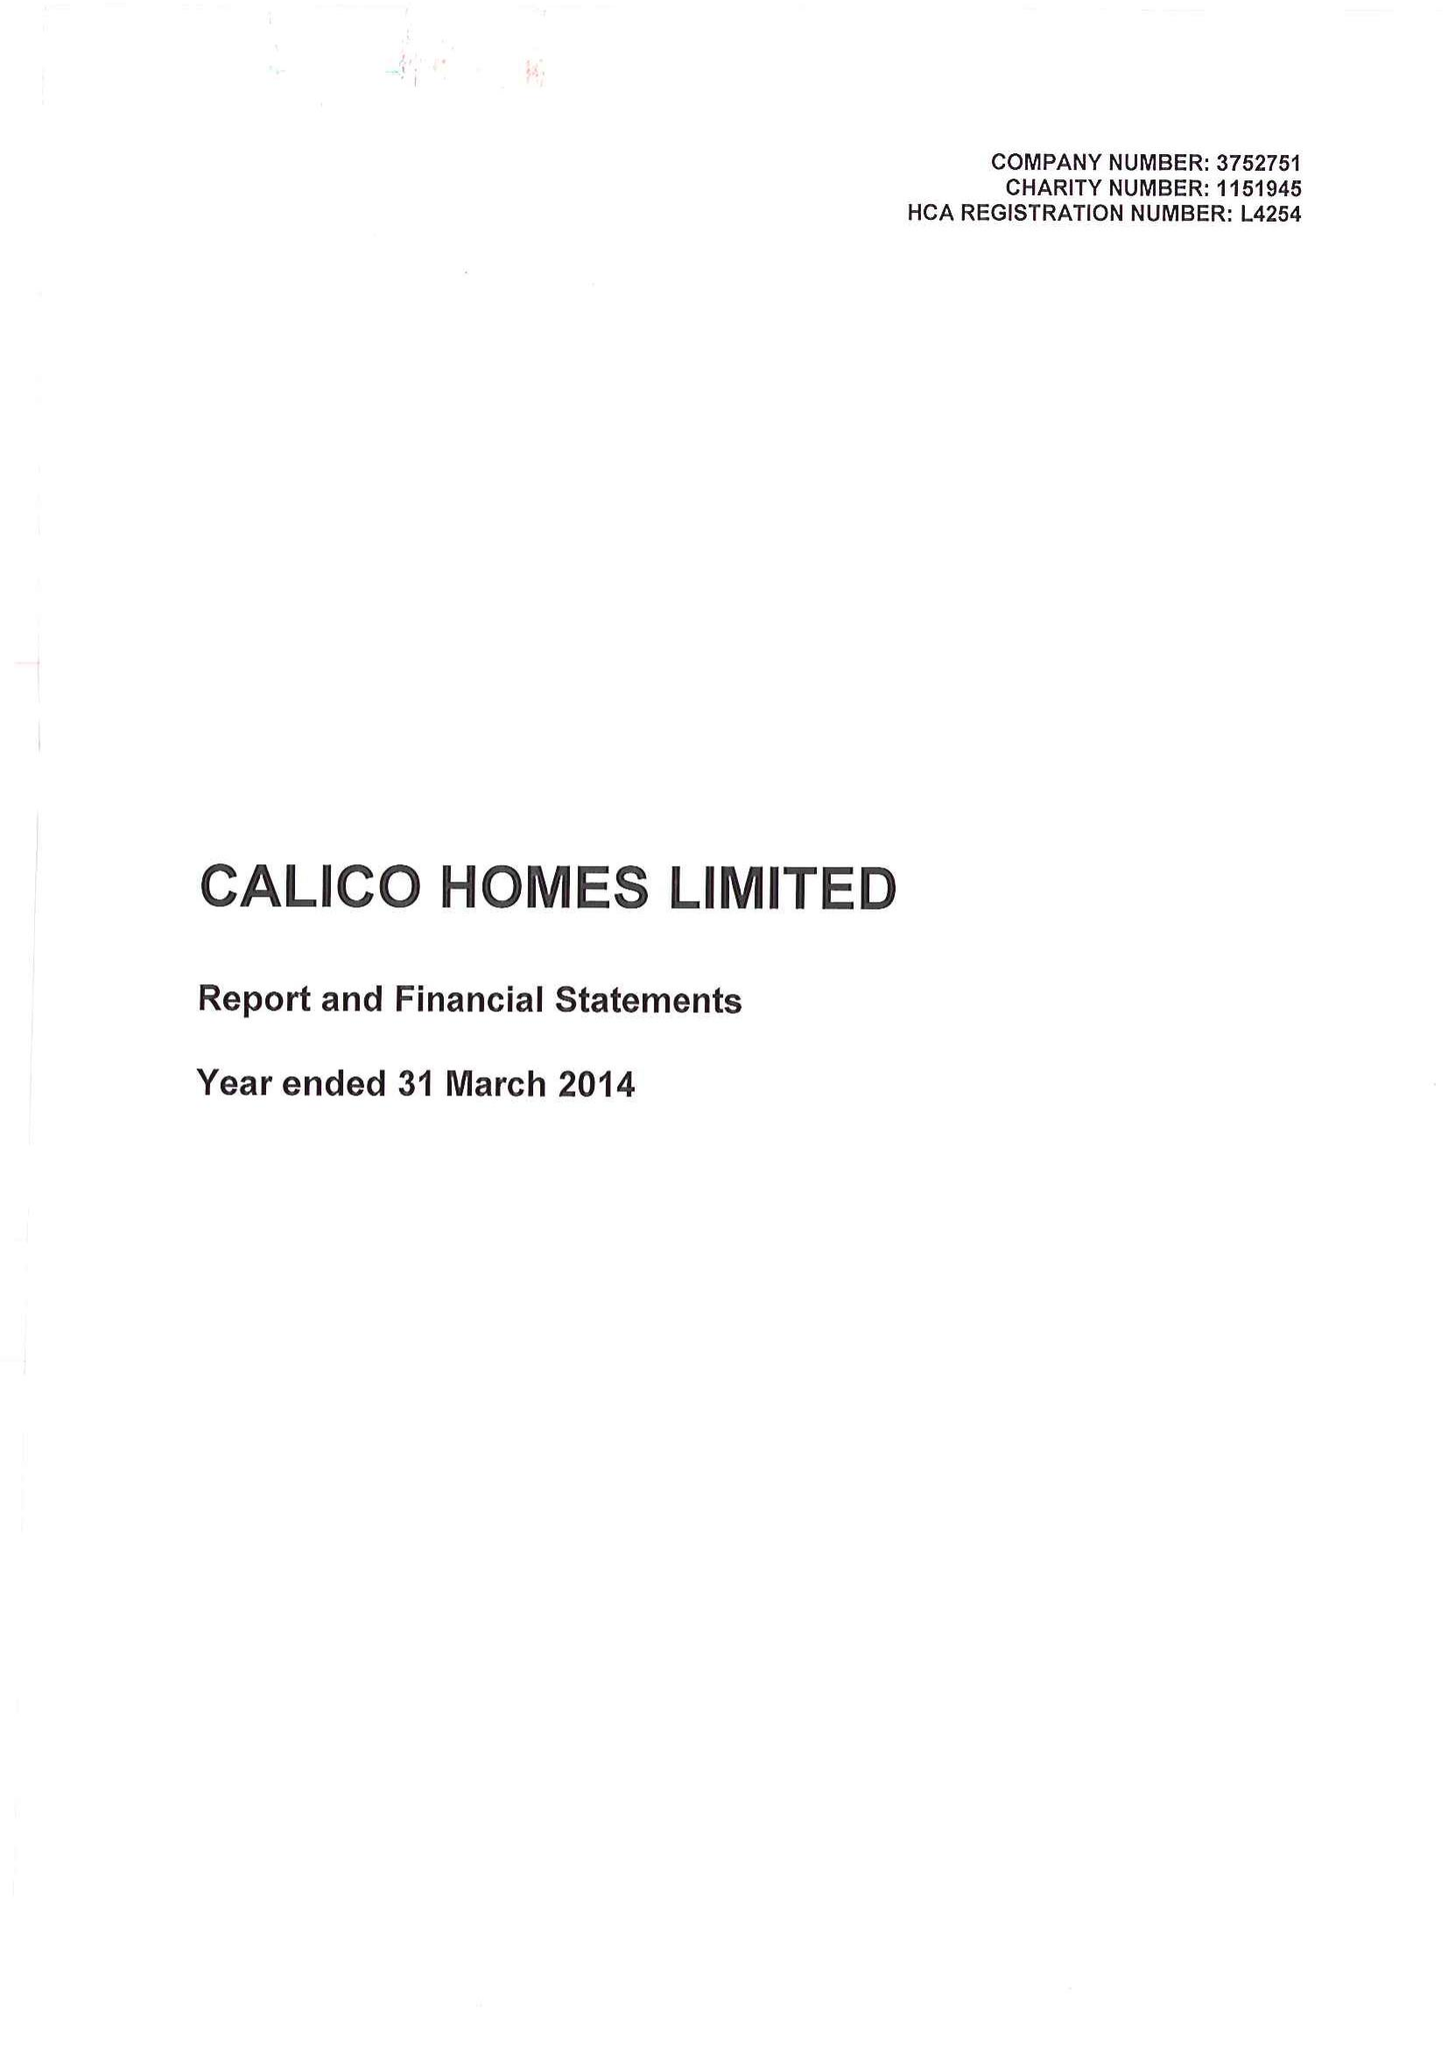What is the value for the address__street_line?
Answer the question using a single word or phrase. CROFT STREET 